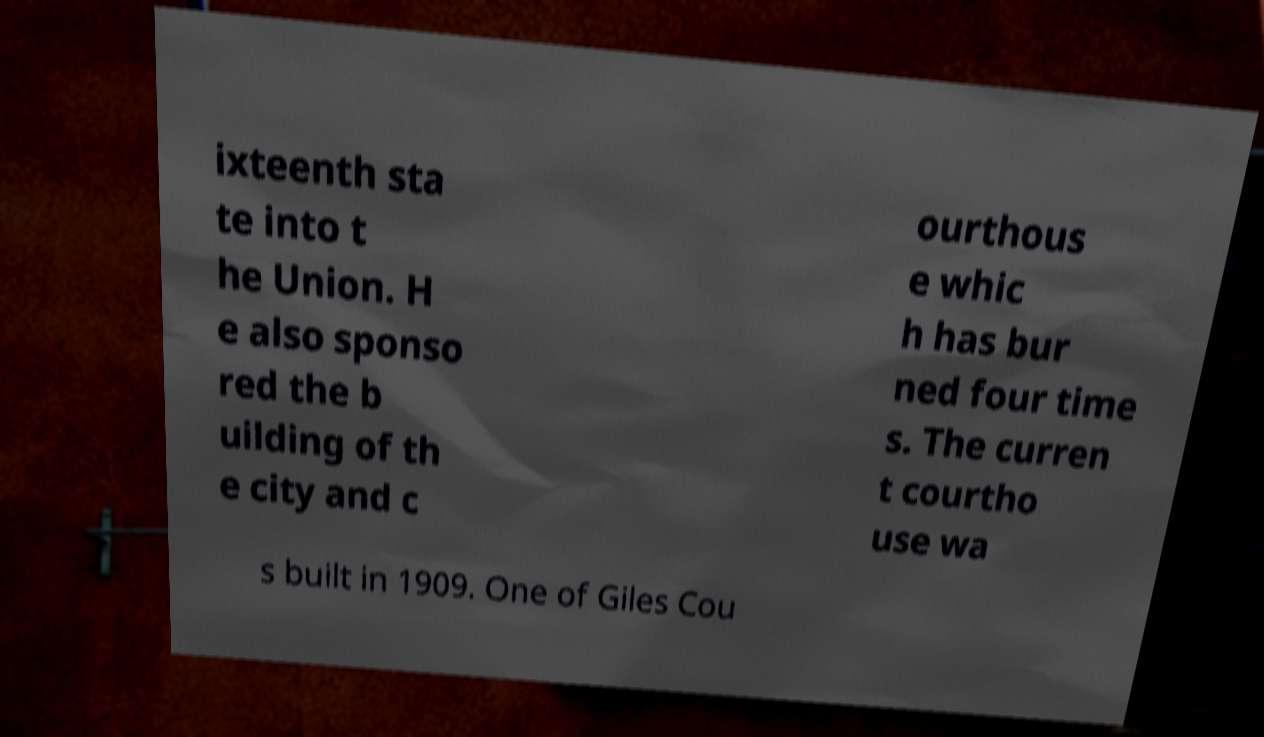Please identify and transcribe the text found in this image. ixteenth sta te into t he Union. H e also sponso red the b uilding of th e city and c ourthous e whic h has bur ned four time s. The curren t courtho use wa s built in 1909. One of Giles Cou 